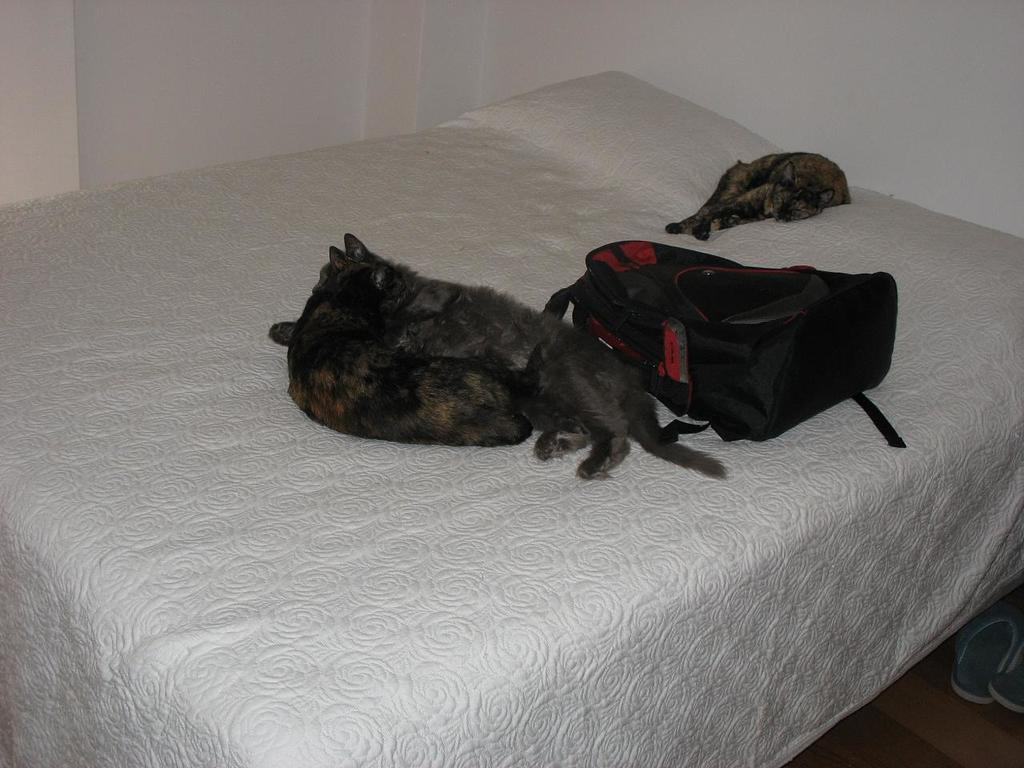How many cats are in the image? There are three cats in the image. What else can be seen in the image besides the cats? There is a black bag in the image. What color is the bed in the image? The bed is white. What time does the clock show in the image? There is no clock present in the image, so it is not possible to determine the time. 